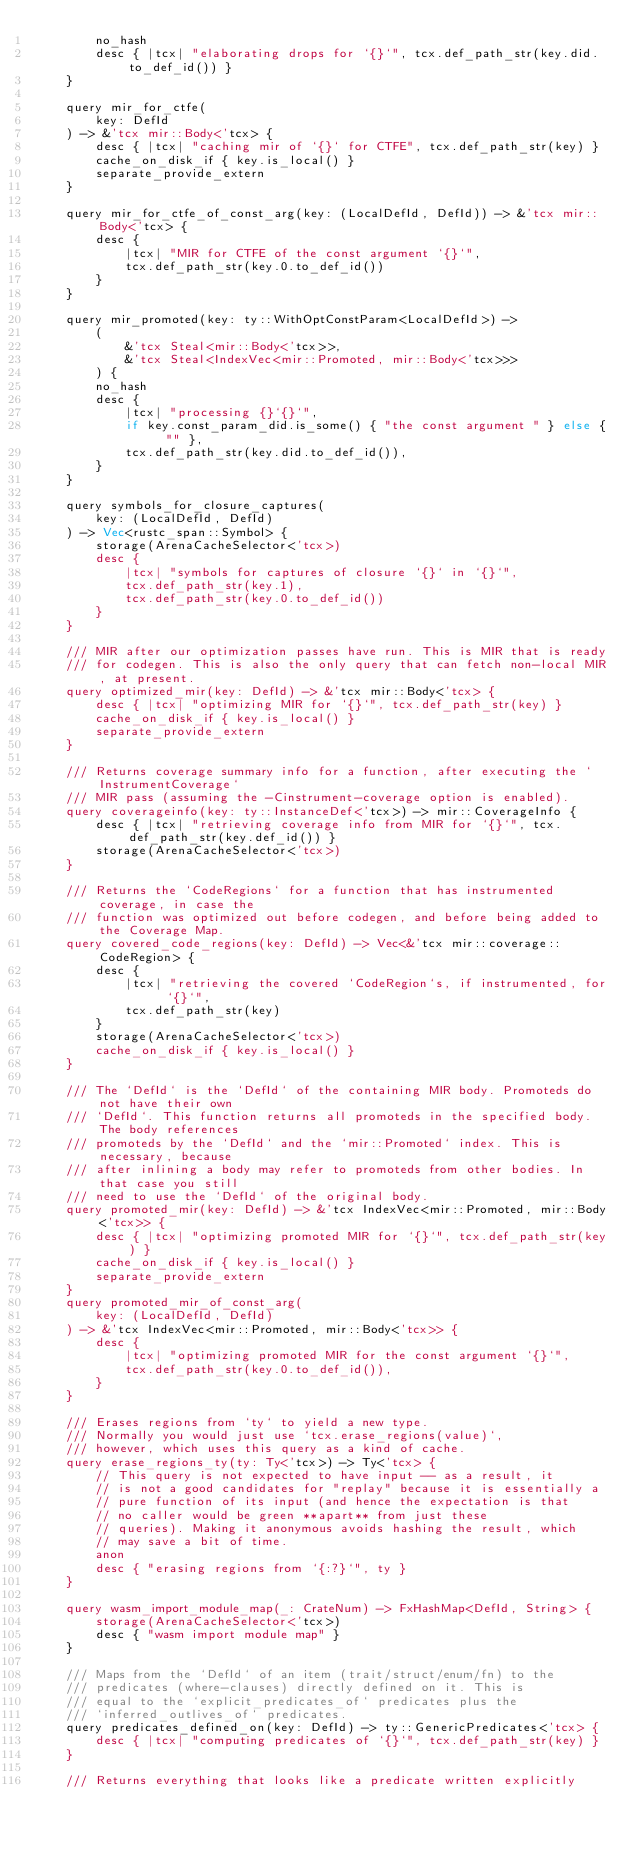Convert code to text. <code><loc_0><loc_0><loc_500><loc_500><_Rust_>        no_hash
        desc { |tcx| "elaborating drops for `{}`", tcx.def_path_str(key.did.to_def_id()) }
    }

    query mir_for_ctfe(
        key: DefId
    ) -> &'tcx mir::Body<'tcx> {
        desc { |tcx| "caching mir of `{}` for CTFE", tcx.def_path_str(key) }
        cache_on_disk_if { key.is_local() }
        separate_provide_extern
    }

    query mir_for_ctfe_of_const_arg(key: (LocalDefId, DefId)) -> &'tcx mir::Body<'tcx> {
        desc {
            |tcx| "MIR for CTFE of the const argument `{}`",
            tcx.def_path_str(key.0.to_def_id())
        }
    }

    query mir_promoted(key: ty::WithOptConstParam<LocalDefId>) ->
        (
            &'tcx Steal<mir::Body<'tcx>>,
            &'tcx Steal<IndexVec<mir::Promoted, mir::Body<'tcx>>>
        ) {
        no_hash
        desc {
            |tcx| "processing {}`{}`",
            if key.const_param_did.is_some() { "the const argument " } else { "" },
            tcx.def_path_str(key.did.to_def_id()),
        }
    }

    query symbols_for_closure_captures(
        key: (LocalDefId, DefId)
    ) -> Vec<rustc_span::Symbol> {
        storage(ArenaCacheSelector<'tcx>)
        desc {
            |tcx| "symbols for captures of closure `{}` in `{}`",
            tcx.def_path_str(key.1),
            tcx.def_path_str(key.0.to_def_id())
        }
    }

    /// MIR after our optimization passes have run. This is MIR that is ready
    /// for codegen. This is also the only query that can fetch non-local MIR, at present.
    query optimized_mir(key: DefId) -> &'tcx mir::Body<'tcx> {
        desc { |tcx| "optimizing MIR for `{}`", tcx.def_path_str(key) }
        cache_on_disk_if { key.is_local() }
        separate_provide_extern
    }

    /// Returns coverage summary info for a function, after executing the `InstrumentCoverage`
    /// MIR pass (assuming the -Cinstrument-coverage option is enabled).
    query coverageinfo(key: ty::InstanceDef<'tcx>) -> mir::CoverageInfo {
        desc { |tcx| "retrieving coverage info from MIR for `{}`", tcx.def_path_str(key.def_id()) }
        storage(ArenaCacheSelector<'tcx>)
    }

    /// Returns the `CodeRegions` for a function that has instrumented coverage, in case the
    /// function was optimized out before codegen, and before being added to the Coverage Map.
    query covered_code_regions(key: DefId) -> Vec<&'tcx mir::coverage::CodeRegion> {
        desc {
            |tcx| "retrieving the covered `CodeRegion`s, if instrumented, for `{}`",
            tcx.def_path_str(key)
        }
        storage(ArenaCacheSelector<'tcx>)
        cache_on_disk_if { key.is_local() }
    }

    /// The `DefId` is the `DefId` of the containing MIR body. Promoteds do not have their own
    /// `DefId`. This function returns all promoteds in the specified body. The body references
    /// promoteds by the `DefId` and the `mir::Promoted` index. This is necessary, because
    /// after inlining a body may refer to promoteds from other bodies. In that case you still
    /// need to use the `DefId` of the original body.
    query promoted_mir(key: DefId) -> &'tcx IndexVec<mir::Promoted, mir::Body<'tcx>> {
        desc { |tcx| "optimizing promoted MIR for `{}`", tcx.def_path_str(key) }
        cache_on_disk_if { key.is_local() }
        separate_provide_extern
    }
    query promoted_mir_of_const_arg(
        key: (LocalDefId, DefId)
    ) -> &'tcx IndexVec<mir::Promoted, mir::Body<'tcx>> {
        desc {
            |tcx| "optimizing promoted MIR for the const argument `{}`",
            tcx.def_path_str(key.0.to_def_id()),
        }
    }

    /// Erases regions from `ty` to yield a new type.
    /// Normally you would just use `tcx.erase_regions(value)`,
    /// however, which uses this query as a kind of cache.
    query erase_regions_ty(ty: Ty<'tcx>) -> Ty<'tcx> {
        // This query is not expected to have input -- as a result, it
        // is not a good candidates for "replay" because it is essentially a
        // pure function of its input (and hence the expectation is that
        // no caller would be green **apart** from just these
        // queries). Making it anonymous avoids hashing the result, which
        // may save a bit of time.
        anon
        desc { "erasing regions from `{:?}`", ty }
    }

    query wasm_import_module_map(_: CrateNum) -> FxHashMap<DefId, String> {
        storage(ArenaCacheSelector<'tcx>)
        desc { "wasm import module map" }
    }

    /// Maps from the `DefId` of an item (trait/struct/enum/fn) to the
    /// predicates (where-clauses) directly defined on it. This is
    /// equal to the `explicit_predicates_of` predicates plus the
    /// `inferred_outlives_of` predicates.
    query predicates_defined_on(key: DefId) -> ty::GenericPredicates<'tcx> {
        desc { |tcx| "computing predicates of `{}`", tcx.def_path_str(key) }
    }

    /// Returns everything that looks like a predicate written explicitly</code> 